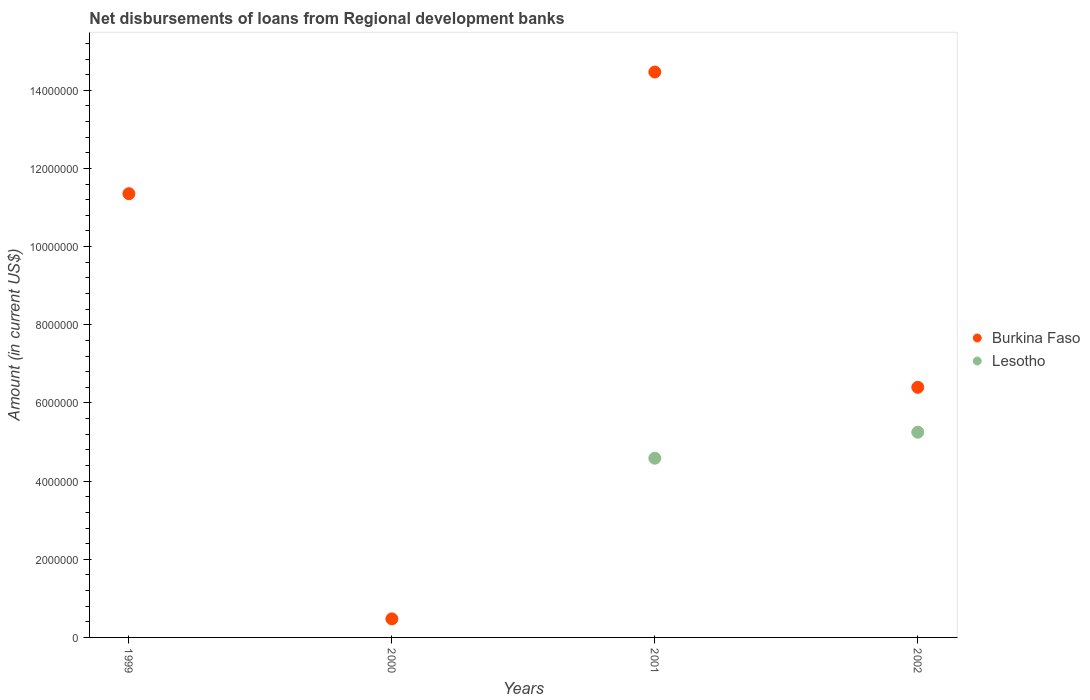How many different coloured dotlines are there?
Offer a terse response. 2. What is the amount of disbursements of loans from regional development banks in Lesotho in 2000?
Offer a very short reply. 0. Across all years, what is the maximum amount of disbursements of loans from regional development banks in Burkina Faso?
Keep it short and to the point. 1.45e+07. Across all years, what is the minimum amount of disbursements of loans from regional development banks in Lesotho?
Your answer should be compact. 0. What is the total amount of disbursements of loans from regional development banks in Burkina Faso in the graph?
Offer a very short reply. 3.27e+07. What is the difference between the amount of disbursements of loans from regional development banks in Burkina Faso in 2000 and that in 2001?
Offer a terse response. -1.40e+07. What is the difference between the amount of disbursements of loans from regional development banks in Burkina Faso in 2000 and the amount of disbursements of loans from regional development banks in Lesotho in 2001?
Your answer should be compact. -4.11e+06. What is the average amount of disbursements of loans from regional development banks in Burkina Faso per year?
Keep it short and to the point. 8.17e+06. In the year 2002, what is the difference between the amount of disbursements of loans from regional development banks in Lesotho and amount of disbursements of loans from regional development banks in Burkina Faso?
Your response must be concise. -1.15e+06. In how many years, is the amount of disbursements of loans from regional development banks in Burkina Faso greater than 10400000 US$?
Your answer should be very brief. 2. What is the ratio of the amount of disbursements of loans from regional development banks in Burkina Faso in 2000 to that in 2002?
Your answer should be compact. 0.07. What is the difference between the highest and the second highest amount of disbursements of loans from regional development banks in Burkina Faso?
Offer a very short reply. 3.11e+06. What is the difference between the highest and the lowest amount of disbursements of loans from regional development banks in Lesotho?
Provide a succinct answer. 5.25e+06. In how many years, is the amount of disbursements of loans from regional development banks in Burkina Faso greater than the average amount of disbursements of loans from regional development banks in Burkina Faso taken over all years?
Ensure brevity in your answer.  2. Is the sum of the amount of disbursements of loans from regional development banks in Burkina Faso in 1999 and 2000 greater than the maximum amount of disbursements of loans from regional development banks in Lesotho across all years?
Provide a succinct answer. Yes. How many years are there in the graph?
Provide a short and direct response. 4. What is the difference between two consecutive major ticks on the Y-axis?
Give a very brief answer. 2.00e+06. Does the graph contain any zero values?
Your answer should be compact. Yes. How many legend labels are there?
Your response must be concise. 2. How are the legend labels stacked?
Your response must be concise. Vertical. What is the title of the graph?
Offer a very short reply. Net disbursements of loans from Regional development banks. What is the label or title of the X-axis?
Provide a short and direct response. Years. What is the Amount (in current US$) in Burkina Faso in 1999?
Provide a short and direct response. 1.14e+07. What is the Amount (in current US$) of Burkina Faso in 2000?
Give a very brief answer. 4.75e+05. What is the Amount (in current US$) of Burkina Faso in 2001?
Offer a very short reply. 1.45e+07. What is the Amount (in current US$) in Lesotho in 2001?
Offer a very short reply. 4.59e+06. What is the Amount (in current US$) in Burkina Faso in 2002?
Give a very brief answer. 6.40e+06. What is the Amount (in current US$) in Lesotho in 2002?
Give a very brief answer. 5.25e+06. Across all years, what is the maximum Amount (in current US$) in Burkina Faso?
Provide a short and direct response. 1.45e+07. Across all years, what is the maximum Amount (in current US$) of Lesotho?
Offer a terse response. 5.25e+06. Across all years, what is the minimum Amount (in current US$) of Burkina Faso?
Offer a very short reply. 4.75e+05. Across all years, what is the minimum Amount (in current US$) in Lesotho?
Your response must be concise. 0. What is the total Amount (in current US$) in Burkina Faso in the graph?
Provide a succinct answer. 3.27e+07. What is the total Amount (in current US$) of Lesotho in the graph?
Make the answer very short. 9.84e+06. What is the difference between the Amount (in current US$) in Burkina Faso in 1999 and that in 2000?
Provide a succinct answer. 1.09e+07. What is the difference between the Amount (in current US$) of Burkina Faso in 1999 and that in 2001?
Make the answer very short. -3.11e+06. What is the difference between the Amount (in current US$) of Burkina Faso in 1999 and that in 2002?
Make the answer very short. 4.96e+06. What is the difference between the Amount (in current US$) of Burkina Faso in 2000 and that in 2001?
Offer a terse response. -1.40e+07. What is the difference between the Amount (in current US$) of Burkina Faso in 2000 and that in 2002?
Keep it short and to the point. -5.92e+06. What is the difference between the Amount (in current US$) in Burkina Faso in 2001 and that in 2002?
Keep it short and to the point. 8.07e+06. What is the difference between the Amount (in current US$) of Lesotho in 2001 and that in 2002?
Offer a terse response. -6.65e+05. What is the difference between the Amount (in current US$) of Burkina Faso in 1999 and the Amount (in current US$) of Lesotho in 2001?
Your answer should be very brief. 6.77e+06. What is the difference between the Amount (in current US$) of Burkina Faso in 1999 and the Amount (in current US$) of Lesotho in 2002?
Ensure brevity in your answer.  6.10e+06. What is the difference between the Amount (in current US$) of Burkina Faso in 2000 and the Amount (in current US$) of Lesotho in 2001?
Your answer should be compact. -4.11e+06. What is the difference between the Amount (in current US$) in Burkina Faso in 2000 and the Amount (in current US$) in Lesotho in 2002?
Give a very brief answer. -4.78e+06. What is the difference between the Amount (in current US$) of Burkina Faso in 2001 and the Amount (in current US$) of Lesotho in 2002?
Give a very brief answer. 9.22e+06. What is the average Amount (in current US$) in Burkina Faso per year?
Keep it short and to the point. 8.17e+06. What is the average Amount (in current US$) in Lesotho per year?
Ensure brevity in your answer.  2.46e+06. In the year 2001, what is the difference between the Amount (in current US$) in Burkina Faso and Amount (in current US$) in Lesotho?
Provide a succinct answer. 9.88e+06. In the year 2002, what is the difference between the Amount (in current US$) in Burkina Faso and Amount (in current US$) in Lesotho?
Your answer should be very brief. 1.15e+06. What is the ratio of the Amount (in current US$) in Burkina Faso in 1999 to that in 2000?
Make the answer very short. 23.91. What is the ratio of the Amount (in current US$) of Burkina Faso in 1999 to that in 2001?
Provide a short and direct response. 0.78. What is the ratio of the Amount (in current US$) in Burkina Faso in 1999 to that in 2002?
Offer a terse response. 1.77. What is the ratio of the Amount (in current US$) in Burkina Faso in 2000 to that in 2001?
Ensure brevity in your answer.  0.03. What is the ratio of the Amount (in current US$) of Burkina Faso in 2000 to that in 2002?
Your answer should be compact. 0.07. What is the ratio of the Amount (in current US$) in Burkina Faso in 2001 to that in 2002?
Offer a terse response. 2.26. What is the ratio of the Amount (in current US$) of Lesotho in 2001 to that in 2002?
Give a very brief answer. 0.87. What is the difference between the highest and the second highest Amount (in current US$) of Burkina Faso?
Your answer should be compact. 3.11e+06. What is the difference between the highest and the lowest Amount (in current US$) of Burkina Faso?
Keep it short and to the point. 1.40e+07. What is the difference between the highest and the lowest Amount (in current US$) of Lesotho?
Provide a short and direct response. 5.25e+06. 